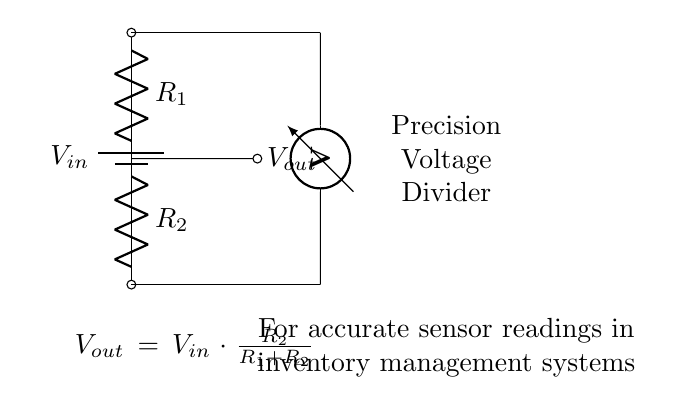What is the input voltage in this circuit? The input voltage is labeled as V in the circuit diagram, which is the voltage applied to the first resistor.
Answer: V in What are the resistance values of the resistors used? The resistors are labeled R one and R two, which represent their respective resistance values in the voltage divider circuit.
Answer: R one and R two What is the formula for calculating the output voltage? The output voltage is given by the formula V out equals V in multiplied by the ratio of R two to the sum of R one and R two.
Answer: V out = V in * (R two / (R one + R two)) How does changing R one affect V out? Increasing the value of R one decreases the output voltage because it increases the denominator in the voltage divider formula, thus reducing the fraction.
Answer: Decreases V out What is the purpose of the voltmeter in this circuit? The voltmeter is used to measure the output voltage V out across R two, providing a visual representation of the voltage level in that part of the circuit.
Answer: Measure V out What is the significance of using a precision voltage divider? A precision voltage divider ensures that the output voltage accurately reflects the input voltage divided by the resistor values, critical for precise sensor readings in inventory management.
Answer: Accurate sensor readings What happens to V out if R two is much larger than R one? If R two is much larger than R one, V out approaches the value of V in, as the output voltage approaches a ratio close to one in the divider equation.
Answer: Approaches V in 